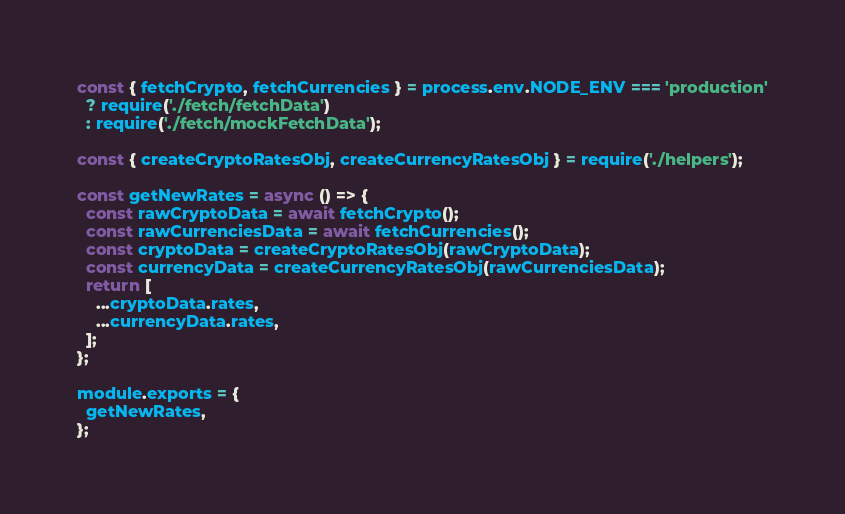<code> <loc_0><loc_0><loc_500><loc_500><_JavaScript_>const { fetchCrypto, fetchCurrencies } = process.env.NODE_ENV === 'production'
  ? require('./fetch/fetchData')
  : require('./fetch/mockFetchData');

const { createCryptoRatesObj, createCurrencyRatesObj } = require('./helpers');

const getNewRates = async () => {
  const rawCryptoData = await fetchCrypto();
  const rawCurrenciesData = await fetchCurrencies();
  const cryptoData = createCryptoRatesObj(rawCryptoData);
  const currencyData = createCurrencyRatesObj(rawCurrenciesData);
  return [
    ...cryptoData.rates,
    ...currencyData.rates,
  ];
};

module.exports = {
  getNewRates,
};
</code> 